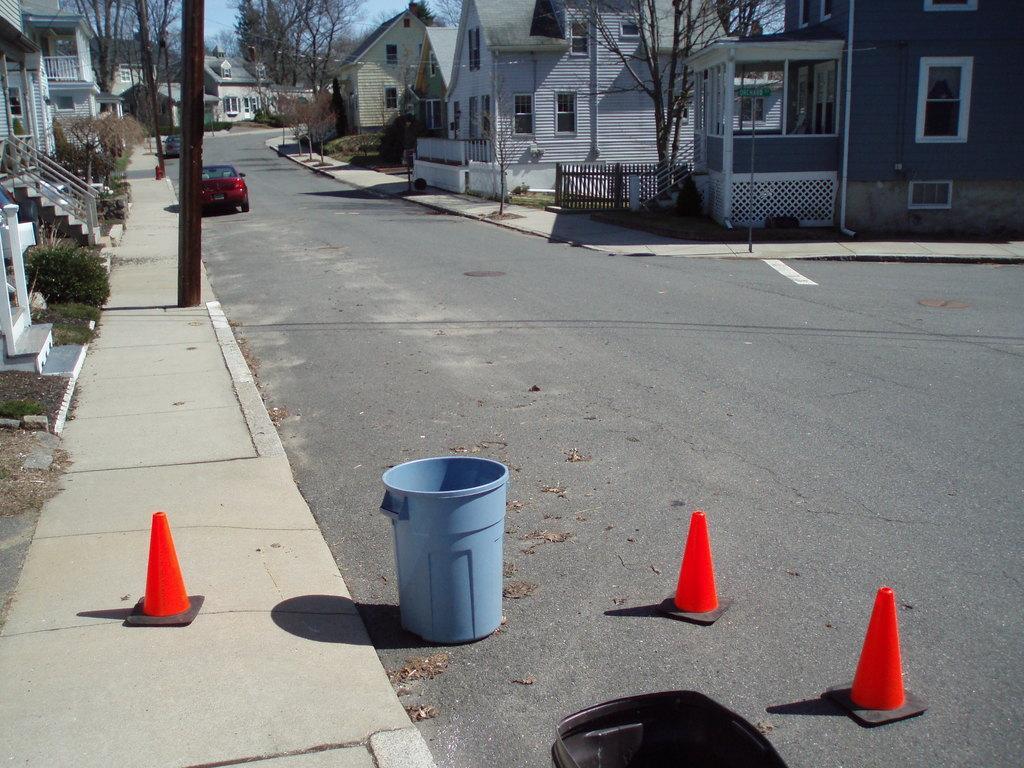Can you describe this image briefly? This image consists of buildings along with road. In the front, there is a dustbin. To the left, there is a pavement. In the background there are buildings along with car on the road. 